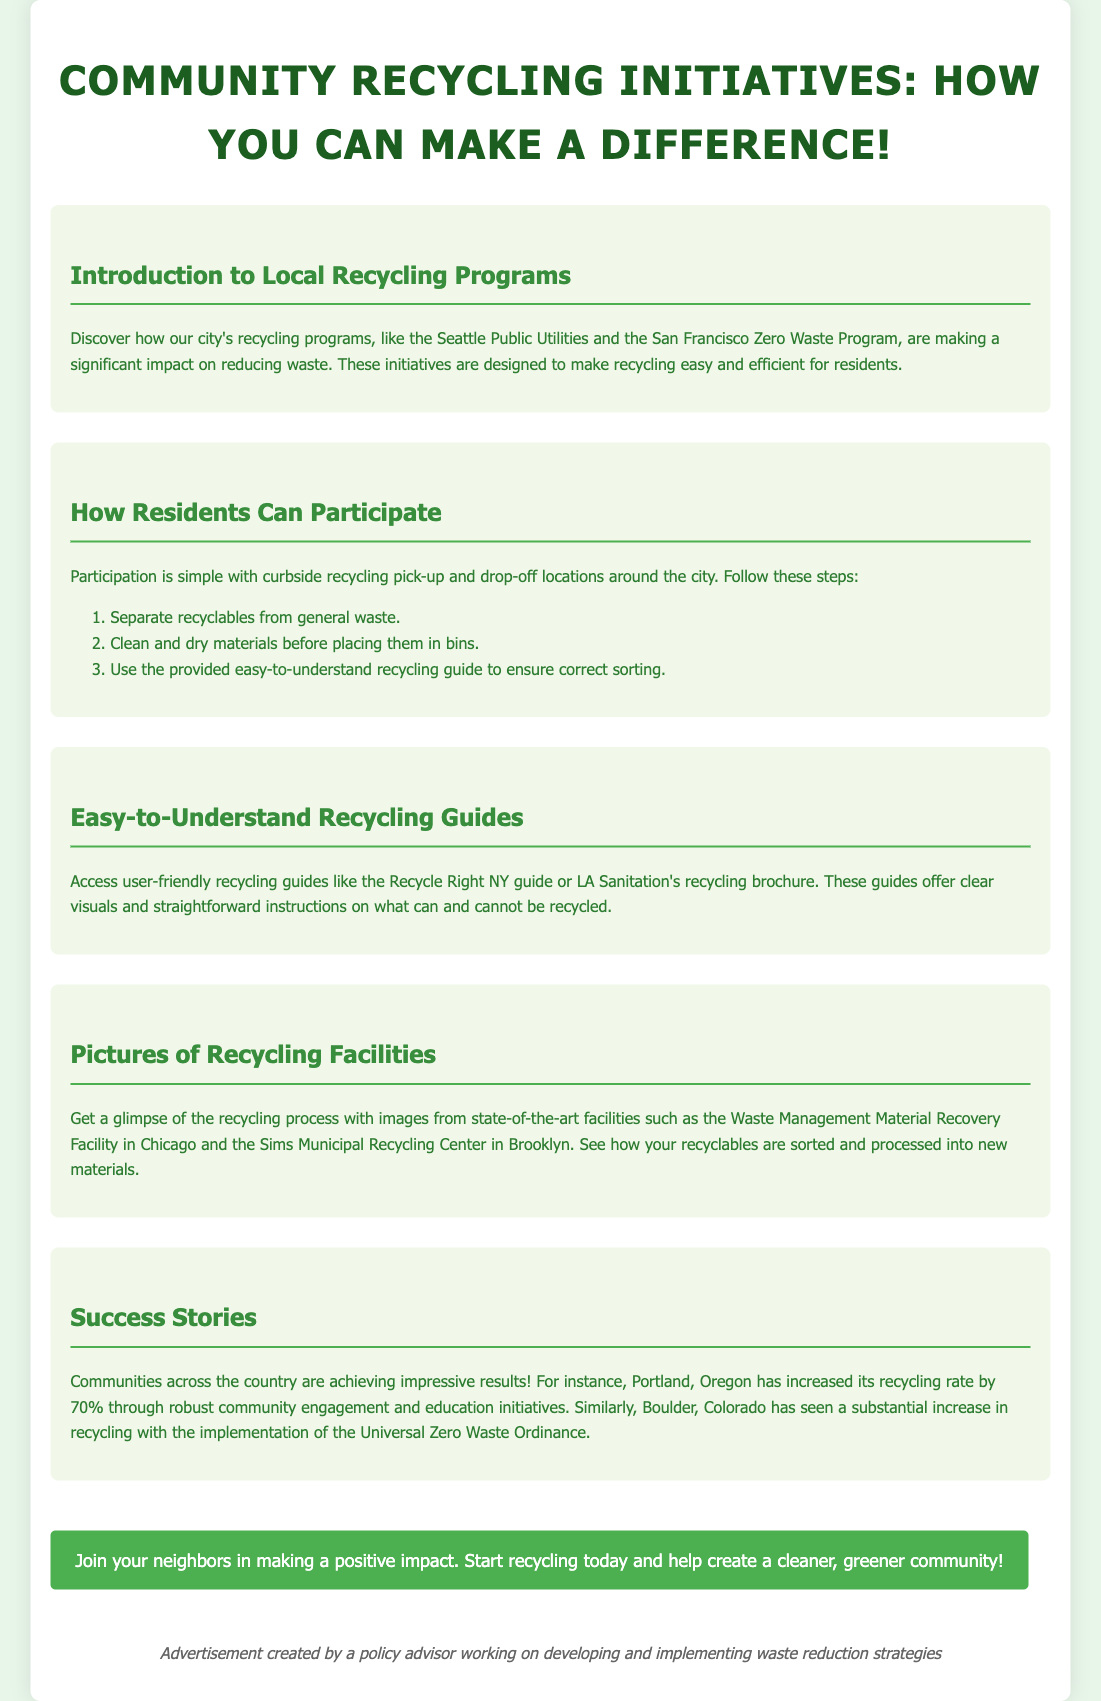What are two examples of city recycling programs? The document mentions "Seattle Public Utilities" and "San Francisco Zero Waste Program" as examples of local recycling programs.
Answer: Seattle Public Utilities, San Francisco Zero Waste Program What is a step residents should take before placing recyclables in bins? The document states that residents should "clean and dry materials before placing them in bins."
Answer: Clean and dry What guide is mentioned for easy recycling instructions? The document refers to guides such as "Recycle Right NY" and "LA Sanitation's recycling brochure" for clear recycling instructions.
Answer: Recycle Right NY, LA Sanitation's recycling brochure What significant increase in recycling was achieved in Portland, Oregon? The document highlights that Portland, Oregon "has increased its recycling rate by 70%."
Answer: 70% What is an example of a facility mentioned in the document? The document cites the "Waste Management Material Recovery Facility in Chicago" as an example of a recycling facility.
Answer: Waste Management Material Recovery Facility in Chicago How can residents participate in recycling according to the document? The document states residents can participate by taking part in "curbside recycling pick-up and drop-off locations."
Answer: Curbside recycling pick-up and drop-off locations What call to action is included in the advertisement? The document encourages readers to "Join your neighbors in making a positive impact. Start recycling today."
Answer: Join your neighbors in making a positive impact. Start recycling today What is the main focus of the advertisement? The document emphasizes the importance of "Community Recycling Initiatives" and how residents can contribute to recycling efforts.
Answer: Community Recycling Initiatives 